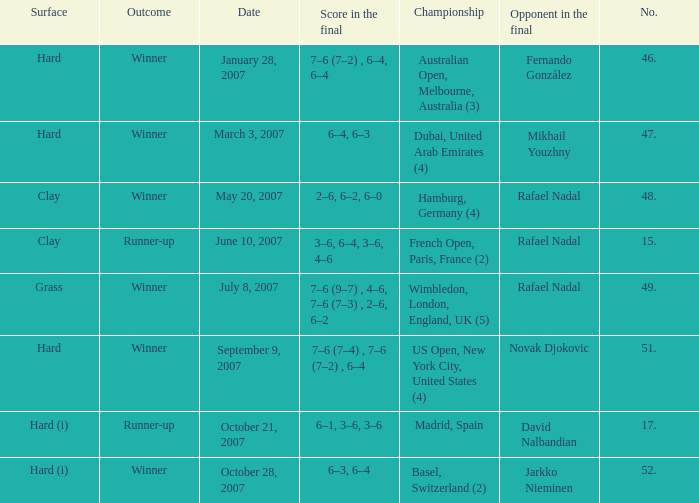When the  score in the final is 3–6, 6–4, 3–6, 4–6, who are all the opponents in the final? Rafael Nadal. 